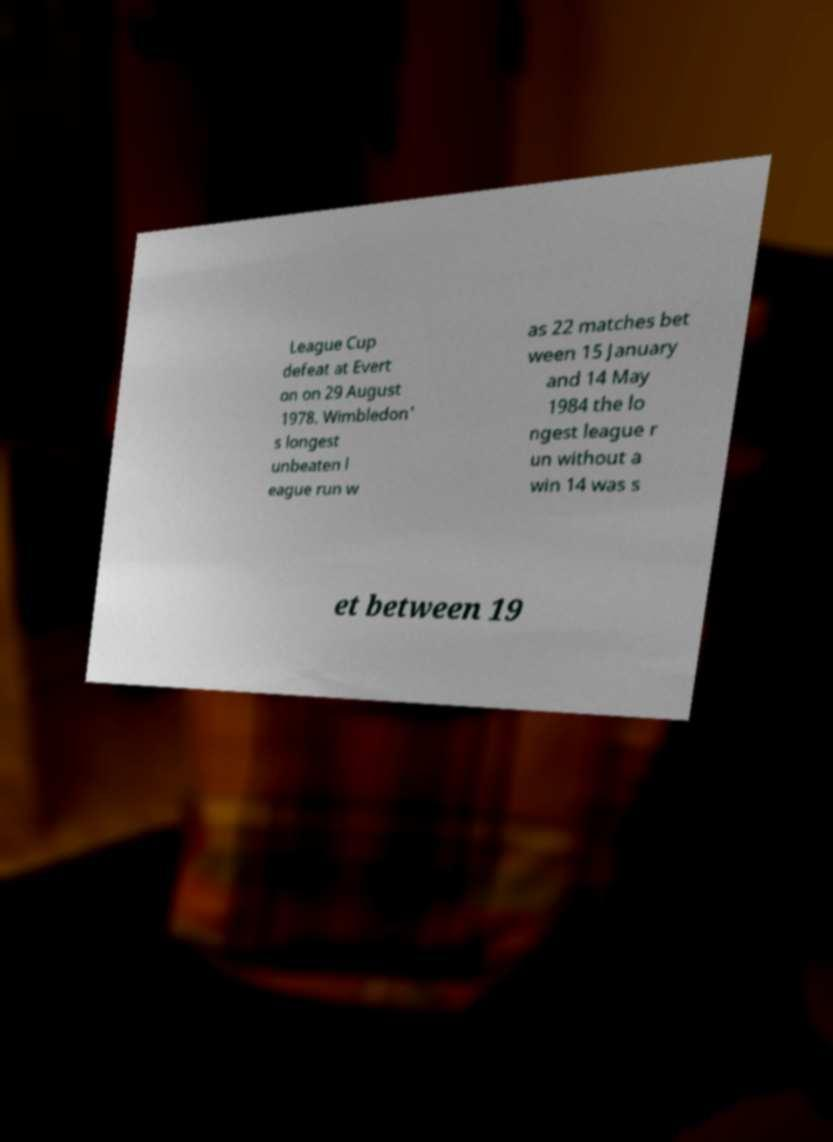Could you assist in decoding the text presented in this image and type it out clearly? League Cup defeat at Evert on on 29 August 1978. Wimbledon' s longest unbeaten l eague run w as 22 matches bet ween 15 January and 14 May 1984 the lo ngest league r un without a win 14 was s et between 19 